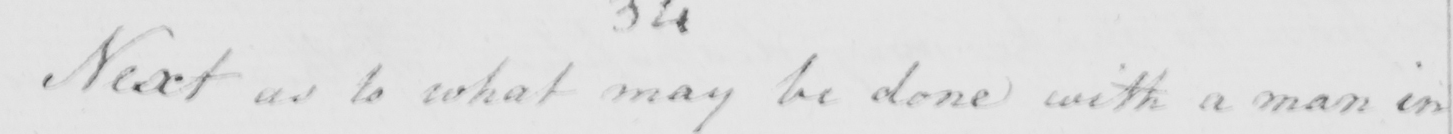Transcribe the text shown in this historical manuscript line. Next as to what may be done with a man in 